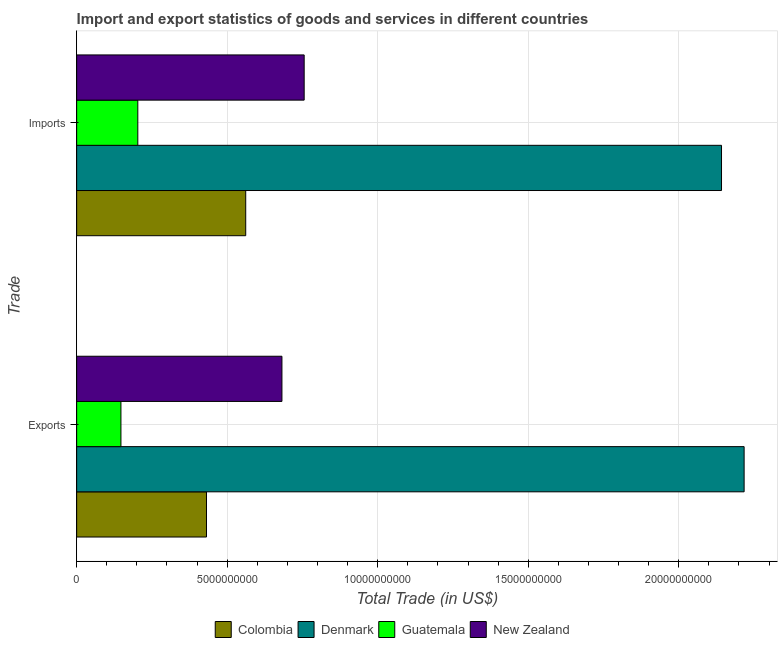How many different coloured bars are there?
Provide a short and direct response. 4. How many groups of bars are there?
Give a very brief answer. 2. Are the number of bars on each tick of the Y-axis equal?
Offer a terse response. Yes. How many bars are there on the 2nd tick from the top?
Your response must be concise. 4. How many bars are there on the 1st tick from the bottom?
Make the answer very short. 4. What is the label of the 2nd group of bars from the top?
Your answer should be very brief. Exports. What is the imports of goods and services in Guatemala?
Your response must be concise. 2.03e+09. Across all countries, what is the maximum imports of goods and services?
Give a very brief answer. 2.14e+1. Across all countries, what is the minimum export of goods and services?
Give a very brief answer. 1.47e+09. In which country was the export of goods and services maximum?
Your answer should be compact. Denmark. In which country was the export of goods and services minimum?
Your answer should be compact. Guatemala. What is the total imports of goods and services in the graph?
Offer a terse response. 3.66e+1. What is the difference between the export of goods and services in Colombia and that in Guatemala?
Offer a terse response. 2.84e+09. What is the difference between the export of goods and services in Guatemala and the imports of goods and services in Denmark?
Ensure brevity in your answer.  -1.99e+1. What is the average imports of goods and services per country?
Offer a terse response. 9.16e+09. What is the difference between the imports of goods and services and export of goods and services in Guatemala?
Ensure brevity in your answer.  5.60e+08. In how many countries, is the imports of goods and services greater than 18000000000 US$?
Keep it short and to the point. 1. What is the ratio of the imports of goods and services in Guatemala to that in Colombia?
Your response must be concise. 0.36. Is the imports of goods and services in Guatemala less than that in New Zealand?
Ensure brevity in your answer.  Yes. How many bars are there?
Ensure brevity in your answer.  8. Are all the bars in the graph horizontal?
Provide a succinct answer. Yes. What is the difference between two consecutive major ticks on the X-axis?
Ensure brevity in your answer.  5.00e+09. Are the values on the major ticks of X-axis written in scientific E-notation?
Provide a short and direct response. No. Does the graph contain grids?
Provide a short and direct response. Yes. How are the legend labels stacked?
Offer a terse response. Horizontal. What is the title of the graph?
Your response must be concise. Import and export statistics of goods and services in different countries. Does "New Caledonia" appear as one of the legend labels in the graph?
Give a very brief answer. No. What is the label or title of the X-axis?
Your answer should be compact. Total Trade (in US$). What is the label or title of the Y-axis?
Provide a short and direct response. Trade. What is the Total Trade (in US$) in Colombia in Exports?
Your answer should be very brief. 4.31e+09. What is the Total Trade (in US$) of Denmark in Exports?
Make the answer very short. 2.22e+1. What is the Total Trade (in US$) in Guatemala in Exports?
Offer a terse response. 1.47e+09. What is the Total Trade (in US$) in New Zealand in Exports?
Provide a short and direct response. 6.82e+09. What is the Total Trade (in US$) of Colombia in Imports?
Your response must be concise. 5.62e+09. What is the Total Trade (in US$) in Denmark in Imports?
Make the answer very short. 2.14e+1. What is the Total Trade (in US$) in Guatemala in Imports?
Your answer should be compact. 2.03e+09. What is the Total Trade (in US$) in New Zealand in Imports?
Your answer should be very brief. 7.56e+09. Across all Trade, what is the maximum Total Trade (in US$) of Colombia?
Provide a short and direct response. 5.62e+09. Across all Trade, what is the maximum Total Trade (in US$) in Denmark?
Offer a very short reply. 2.22e+1. Across all Trade, what is the maximum Total Trade (in US$) of Guatemala?
Your answer should be very brief. 2.03e+09. Across all Trade, what is the maximum Total Trade (in US$) of New Zealand?
Make the answer very short. 7.56e+09. Across all Trade, what is the minimum Total Trade (in US$) in Colombia?
Offer a terse response. 4.31e+09. Across all Trade, what is the minimum Total Trade (in US$) in Denmark?
Ensure brevity in your answer.  2.14e+1. Across all Trade, what is the minimum Total Trade (in US$) of Guatemala?
Give a very brief answer. 1.47e+09. Across all Trade, what is the minimum Total Trade (in US$) in New Zealand?
Provide a short and direct response. 6.82e+09. What is the total Total Trade (in US$) of Colombia in the graph?
Make the answer very short. 9.93e+09. What is the total Total Trade (in US$) in Denmark in the graph?
Offer a very short reply. 4.36e+1. What is the total Total Trade (in US$) in Guatemala in the graph?
Ensure brevity in your answer.  3.50e+09. What is the total Total Trade (in US$) of New Zealand in the graph?
Your response must be concise. 1.44e+1. What is the difference between the Total Trade (in US$) of Colombia in Exports and that in Imports?
Give a very brief answer. -1.30e+09. What is the difference between the Total Trade (in US$) of Denmark in Exports and that in Imports?
Keep it short and to the point. 7.51e+08. What is the difference between the Total Trade (in US$) in Guatemala in Exports and that in Imports?
Provide a succinct answer. -5.60e+08. What is the difference between the Total Trade (in US$) in New Zealand in Exports and that in Imports?
Offer a terse response. -7.39e+08. What is the difference between the Total Trade (in US$) of Colombia in Exports and the Total Trade (in US$) of Denmark in Imports?
Keep it short and to the point. -1.71e+1. What is the difference between the Total Trade (in US$) in Colombia in Exports and the Total Trade (in US$) in Guatemala in Imports?
Offer a terse response. 2.28e+09. What is the difference between the Total Trade (in US$) of Colombia in Exports and the Total Trade (in US$) of New Zealand in Imports?
Provide a succinct answer. -3.24e+09. What is the difference between the Total Trade (in US$) in Denmark in Exports and the Total Trade (in US$) in Guatemala in Imports?
Provide a short and direct response. 2.01e+1. What is the difference between the Total Trade (in US$) of Denmark in Exports and the Total Trade (in US$) of New Zealand in Imports?
Your answer should be compact. 1.46e+1. What is the difference between the Total Trade (in US$) in Guatemala in Exports and the Total Trade (in US$) in New Zealand in Imports?
Ensure brevity in your answer.  -6.09e+09. What is the average Total Trade (in US$) of Colombia per Trade?
Your answer should be very brief. 4.96e+09. What is the average Total Trade (in US$) of Denmark per Trade?
Give a very brief answer. 2.18e+1. What is the average Total Trade (in US$) in Guatemala per Trade?
Keep it short and to the point. 1.75e+09. What is the average Total Trade (in US$) in New Zealand per Trade?
Your answer should be very brief. 7.19e+09. What is the difference between the Total Trade (in US$) of Colombia and Total Trade (in US$) of Denmark in Exports?
Give a very brief answer. -1.79e+1. What is the difference between the Total Trade (in US$) in Colombia and Total Trade (in US$) in Guatemala in Exports?
Your answer should be very brief. 2.84e+09. What is the difference between the Total Trade (in US$) in Colombia and Total Trade (in US$) in New Zealand in Exports?
Provide a succinct answer. -2.51e+09. What is the difference between the Total Trade (in US$) in Denmark and Total Trade (in US$) in Guatemala in Exports?
Your answer should be compact. 2.07e+1. What is the difference between the Total Trade (in US$) in Denmark and Total Trade (in US$) in New Zealand in Exports?
Keep it short and to the point. 1.54e+1. What is the difference between the Total Trade (in US$) in Guatemala and Total Trade (in US$) in New Zealand in Exports?
Offer a very short reply. -5.35e+09. What is the difference between the Total Trade (in US$) in Colombia and Total Trade (in US$) in Denmark in Imports?
Make the answer very short. -1.58e+1. What is the difference between the Total Trade (in US$) in Colombia and Total Trade (in US$) in Guatemala in Imports?
Your response must be concise. 3.58e+09. What is the difference between the Total Trade (in US$) of Colombia and Total Trade (in US$) of New Zealand in Imports?
Provide a short and direct response. -1.94e+09. What is the difference between the Total Trade (in US$) in Denmark and Total Trade (in US$) in Guatemala in Imports?
Make the answer very short. 1.94e+1. What is the difference between the Total Trade (in US$) in Denmark and Total Trade (in US$) in New Zealand in Imports?
Ensure brevity in your answer.  1.39e+1. What is the difference between the Total Trade (in US$) of Guatemala and Total Trade (in US$) of New Zealand in Imports?
Your answer should be very brief. -5.53e+09. What is the ratio of the Total Trade (in US$) in Colombia in Exports to that in Imports?
Your response must be concise. 0.77. What is the ratio of the Total Trade (in US$) of Denmark in Exports to that in Imports?
Your response must be concise. 1.04. What is the ratio of the Total Trade (in US$) in Guatemala in Exports to that in Imports?
Ensure brevity in your answer.  0.72. What is the ratio of the Total Trade (in US$) of New Zealand in Exports to that in Imports?
Your answer should be very brief. 0.9. What is the difference between the highest and the second highest Total Trade (in US$) of Colombia?
Provide a short and direct response. 1.30e+09. What is the difference between the highest and the second highest Total Trade (in US$) in Denmark?
Ensure brevity in your answer.  7.51e+08. What is the difference between the highest and the second highest Total Trade (in US$) in Guatemala?
Offer a terse response. 5.60e+08. What is the difference between the highest and the second highest Total Trade (in US$) of New Zealand?
Provide a succinct answer. 7.39e+08. What is the difference between the highest and the lowest Total Trade (in US$) in Colombia?
Make the answer very short. 1.30e+09. What is the difference between the highest and the lowest Total Trade (in US$) in Denmark?
Offer a very short reply. 7.51e+08. What is the difference between the highest and the lowest Total Trade (in US$) in Guatemala?
Offer a terse response. 5.60e+08. What is the difference between the highest and the lowest Total Trade (in US$) in New Zealand?
Make the answer very short. 7.39e+08. 